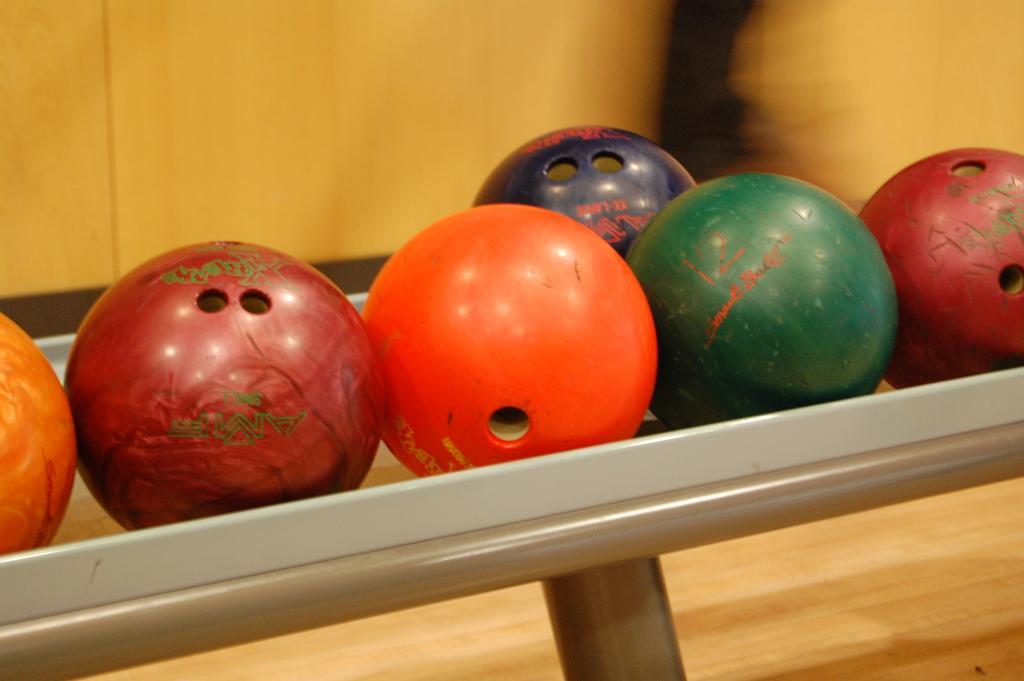Can you describe this image briefly? In the center of the image there are balls. In the background of the image there is a wooden wall. At the bottom of the image there is a wooden surface. 